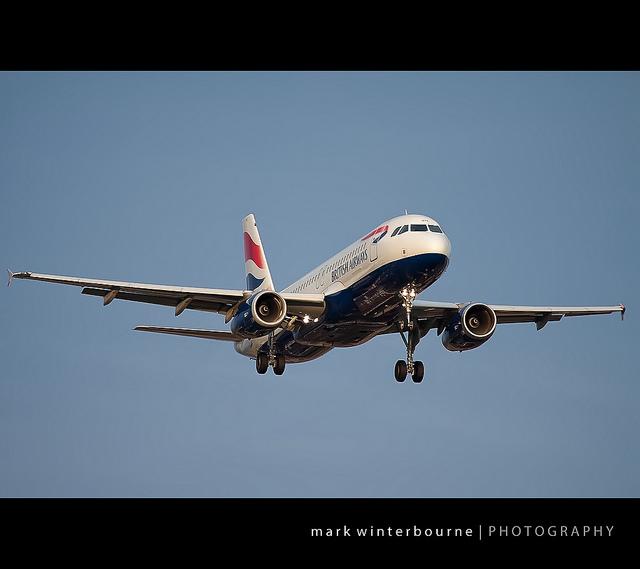IS the plane flying?
Keep it brief. Yes. Are four of the cockpit windows showing?
Short answer required. Yes. Is the landing gear deployed?
Quick response, please. Yes. 